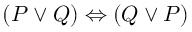Convert formula to latex. <formula><loc_0><loc_0><loc_500><loc_500>( P \lor Q ) \Leftrightarrow ( Q \lor P )</formula> 